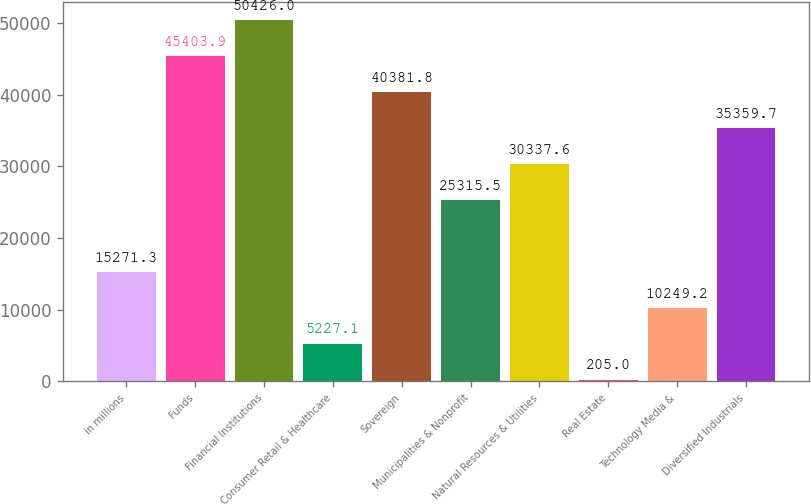Convert chart to OTSL. <chart><loc_0><loc_0><loc_500><loc_500><bar_chart><fcel>in millions<fcel>Funds<fcel>Financial Institutions<fcel>Consumer Retail & Healthcare<fcel>Sovereign<fcel>Municipalities & Nonprofit<fcel>Natural Resources & Utilities<fcel>Real Estate<fcel>Technology Media &<fcel>Diversified Industrials<nl><fcel>15271.3<fcel>45403.9<fcel>50426<fcel>5227.1<fcel>40381.8<fcel>25315.5<fcel>30337.6<fcel>205<fcel>10249.2<fcel>35359.7<nl></chart> 